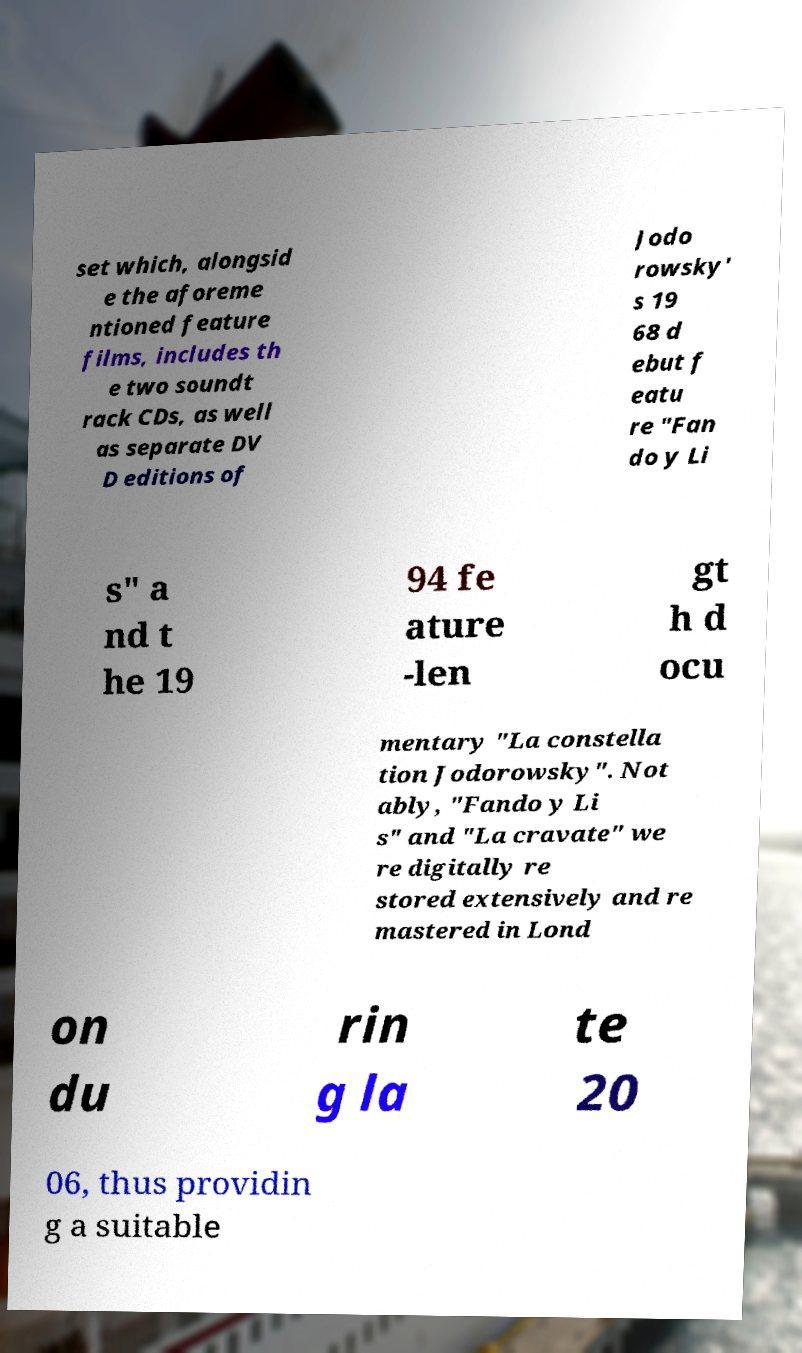Can you read and provide the text displayed in the image?This photo seems to have some interesting text. Can you extract and type it out for me? set which, alongsid e the aforeme ntioned feature films, includes th e two soundt rack CDs, as well as separate DV D editions of Jodo rowsky' s 19 68 d ebut f eatu re "Fan do y Li s" a nd t he 19 94 fe ature -len gt h d ocu mentary "La constella tion Jodorowsky". Not ably, "Fando y Li s" and "La cravate" we re digitally re stored extensively and re mastered in Lond on du rin g la te 20 06, thus providin g a suitable 